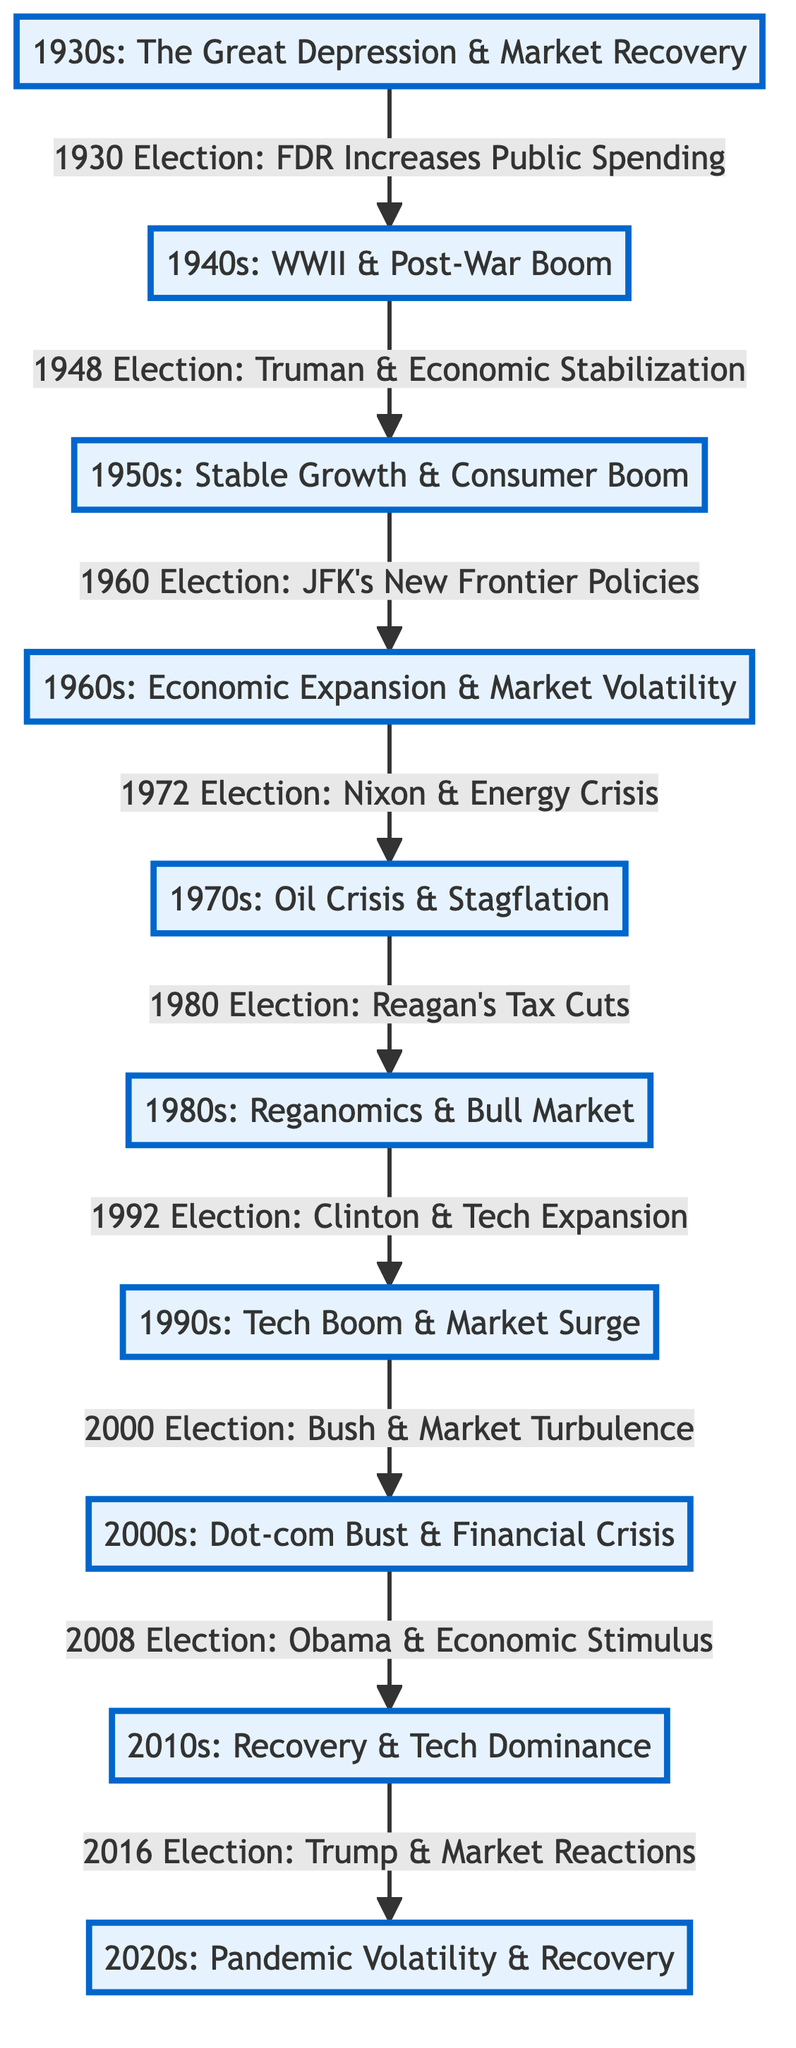What decade is associated with the Great Depression and market recovery? The diagram shows that the 1930s is labeled as the decade that corresponds to the Great Depression and market recovery.
Answer: 1930s What significant event occurred in the 1980 election? The diagram indicates that the 1980 election is linked to Reagan's tax cuts, showing the key impact of this election on the market during that decade.
Answer: Reagan's Tax Cuts Which decade experienced the Tech Boom and market surge? Referring to the diagram, the 1990s is clearly labeled as the decade associated with the Tech Boom and market surge, highlighting its prominence.
Answer: 1990s How many election years are highlighted in the diagram? By counting the arrows leading from nodes labeled with election years, we find there are eight specific elections indicated, marking significant transitions between decades.
Answer: 8 What was the impact of the 2008 election according to the diagram? The diagram notes that the 2008 election is tied to Obama's economic stimulus, which was pivotal amidst the financial crisis of the 2000s, indicating its effect on recovery.
Answer: Economic Stimulus What does the arrow from the 1940s to the 1950s signify? The arrow from 1940s to 1950s signifies that the event in the 1948 election involving Truman's economic stabilization influenced the subsequent decade's growth.
Answer: Economic Stabilization Which election year is linked to Nixon and the energy crisis? The diagram specifies that the 1972 election is associated with Nixon's involvement during the energy crisis, marking a significant historical link.
Answer: 1972 Election What event connects the 2010s to the 2020s? The transition from the 2010s to the 2020s is captured by the 2016 election, indicating that Trump's market reactions played a role in the shifts observed between these decades.
Answer: Trump & Market Reactions 